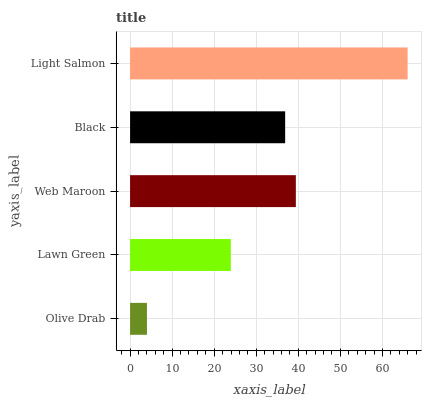Is Olive Drab the minimum?
Answer yes or no. Yes. Is Light Salmon the maximum?
Answer yes or no. Yes. Is Lawn Green the minimum?
Answer yes or no. No. Is Lawn Green the maximum?
Answer yes or no. No. Is Lawn Green greater than Olive Drab?
Answer yes or no. Yes. Is Olive Drab less than Lawn Green?
Answer yes or no. Yes. Is Olive Drab greater than Lawn Green?
Answer yes or no. No. Is Lawn Green less than Olive Drab?
Answer yes or no. No. Is Black the high median?
Answer yes or no. Yes. Is Black the low median?
Answer yes or no. Yes. Is Olive Drab the high median?
Answer yes or no. No. Is Web Maroon the low median?
Answer yes or no. No. 